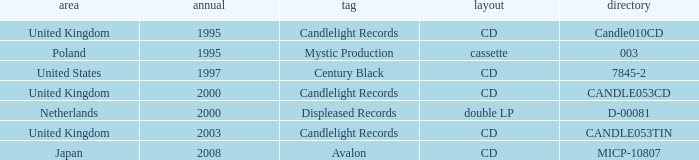Parse the full table. {'header': ['area', 'annual', 'tag', 'layout', 'directory'], 'rows': [['United Kingdom', '1995', 'Candlelight Records', 'CD', 'Candle010CD'], ['Poland', '1995', 'Mystic Production', 'cassette', '003'], ['United States', '1997', 'Century Black', 'CD', '7845-2'], ['United Kingdom', '2000', 'Candlelight Records', 'CD', 'CANDLE053CD'], ['Netherlands', '2000', 'Displeased Records', 'double LP', 'D-00081'], ['United Kingdom', '2003', 'Candlelight Records', 'CD', 'CANDLE053TIN'], ['Japan', '2008', 'Avalon', 'CD', 'MICP-10807']]} What year did Japan form a label? 2008.0. 